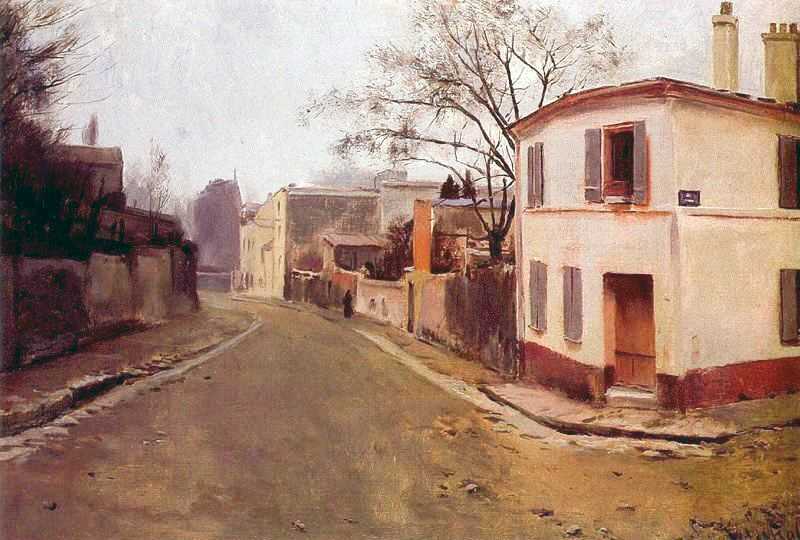What do you think is going on in this snapshot? The image is an oil painting that captures a serene street scene in a small town. The artist uses an impressionist style characterized by loose brushstrokes, which emphasize the overall atmosphere over precise details. The color palette features muted tones like browns, grays, and greens, which convey a sense of tranquility. The scene centers on a quiet street lined with houses and surrounded by leafless trees, suggesting a calm, perhaps winter or early spring day. The absence of people adds to the peacefulness, making it feel like a snapshot of a quiet, idyllic town moment. 